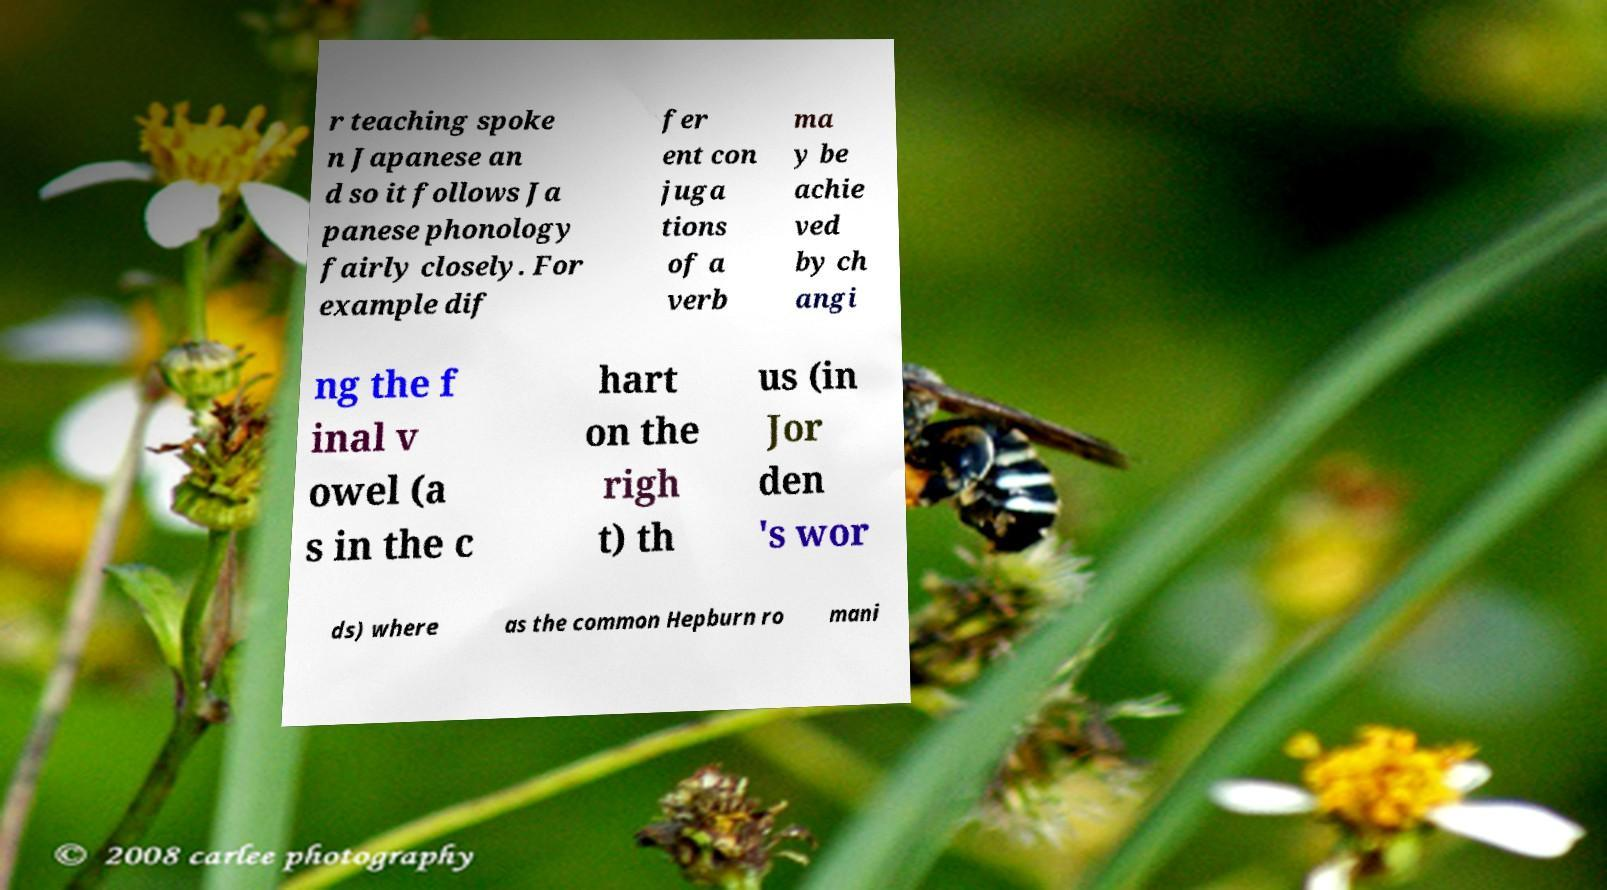I need the written content from this picture converted into text. Can you do that? r teaching spoke n Japanese an d so it follows Ja panese phonology fairly closely. For example dif fer ent con juga tions of a verb ma y be achie ved by ch angi ng the f inal v owel (a s in the c hart on the righ t) th us (in Jor den 's wor ds) where as the common Hepburn ro mani 